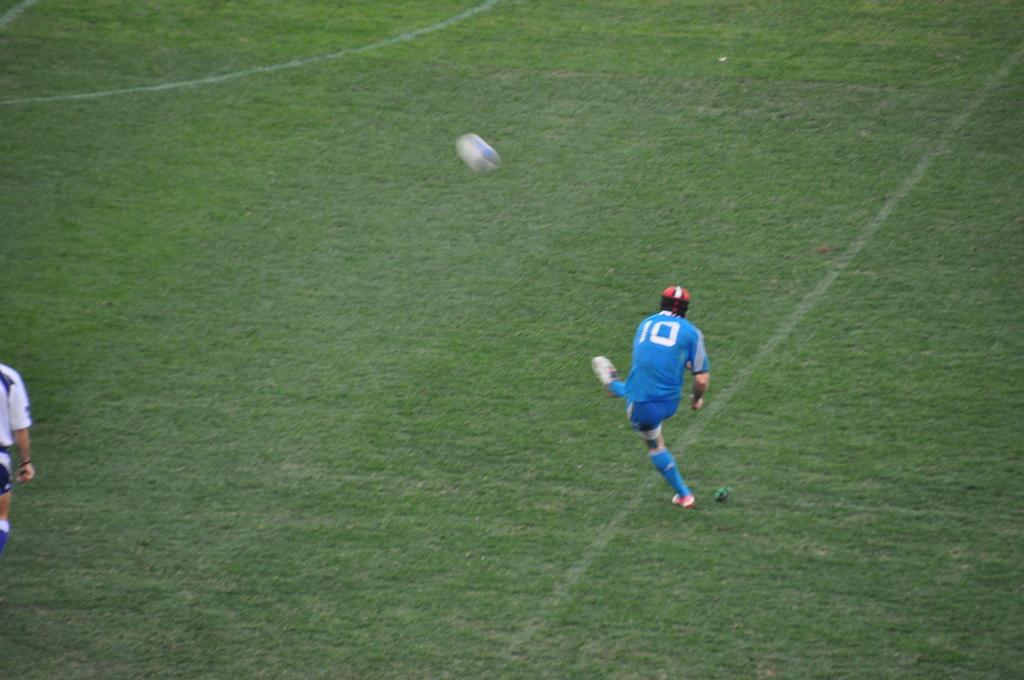Can you describe this image briefly? In this image, I can see two persons on the ground. There is a ball. 